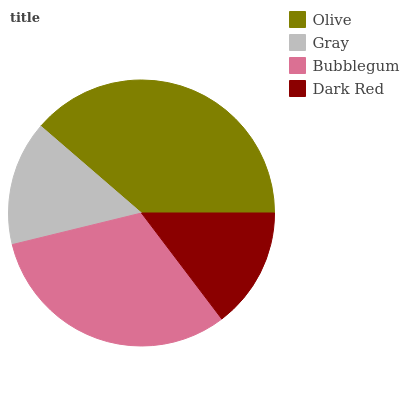Is Dark Red the minimum?
Answer yes or no. Yes. Is Olive the maximum?
Answer yes or no. Yes. Is Gray the minimum?
Answer yes or no. No. Is Gray the maximum?
Answer yes or no. No. Is Olive greater than Gray?
Answer yes or no. Yes. Is Gray less than Olive?
Answer yes or no. Yes. Is Gray greater than Olive?
Answer yes or no. No. Is Olive less than Gray?
Answer yes or no. No. Is Bubblegum the high median?
Answer yes or no. Yes. Is Gray the low median?
Answer yes or no. Yes. Is Dark Red the high median?
Answer yes or no. No. Is Olive the low median?
Answer yes or no. No. 